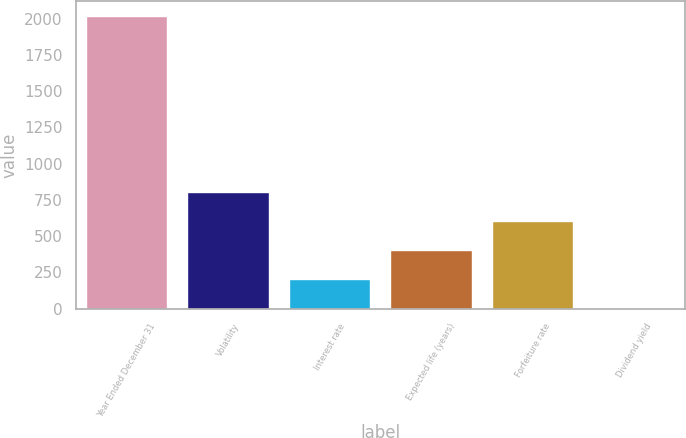<chart> <loc_0><loc_0><loc_500><loc_500><bar_chart><fcel>Year Ended December 31<fcel>Volatility<fcel>Interest rate<fcel>Expected life (years)<fcel>Forfeiture rate<fcel>Dividend yield<nl><fcel>2018<fcel>807.38<fcel>202.07<fcel>403.84<fcel>605.61<fcel>0.3<nl></chart> 